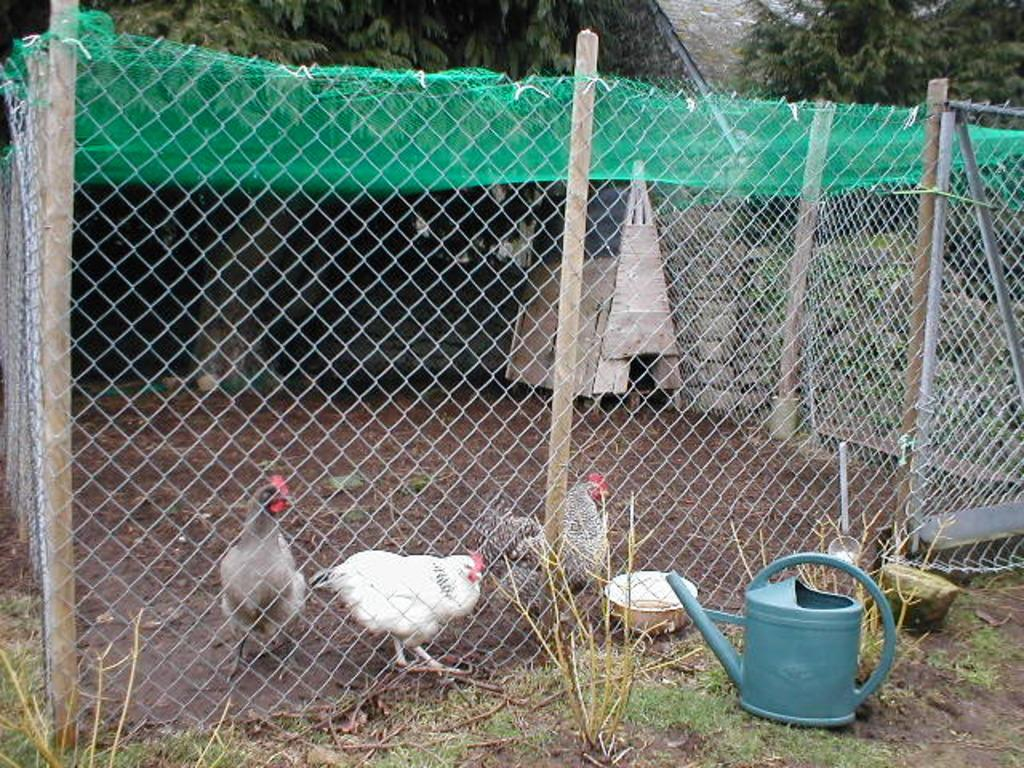What animals can be seen on the ground in the image? There are three hens on the ground in the image. What is in front of the hens? There is a fencing grill and a grey color water jug in front of the hens. What type of structure can be seen on the top of the image? There is a green shed visible on the top of the image. What type of vegetation is present on the back side of the image? There are trees present on the back side of the image. What subject are the hens teaching in the image? There is no indication in the image that the hens are teaching any subject. 